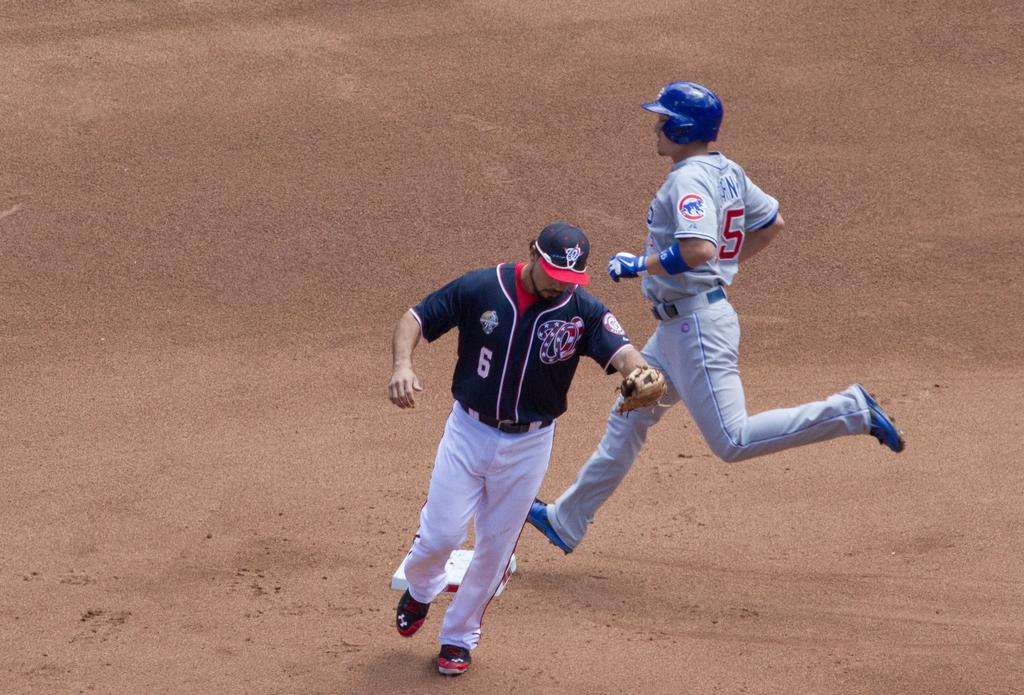<image>
Relay a brief, clear account of the picture shown. Baseball player wearing jersey number 5 running to base. 